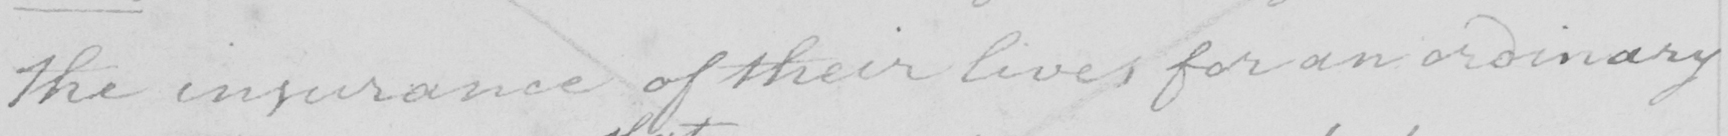Can you read and transcribe this handwriting? the insurance of their lives , for an ordinary 